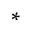Convert formula to latex. <formula><loc_0><loc_0><loc_500><loc_500>^ { * }</formula> 